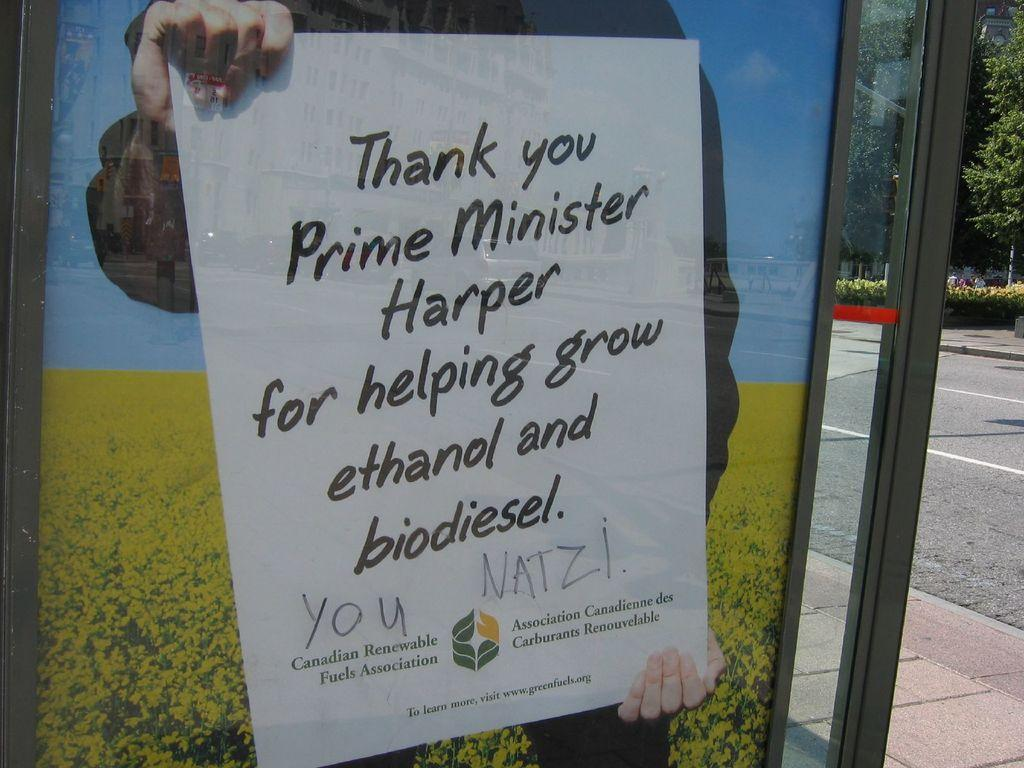What is the main object in the image? There is a board in the image. Who is holding the board? A person is holding the board. What can be seen behind the board? There are plants visible behind the board. What is visible in the background of the image? There is a road and trees present in the background of the image. What type of vegetation is visible in the background of the image? Plants are visible in the background of the image. What type of hook can be seen hanging from the board in the image? There is no hook present on the board in the image. What sound can be heard coming from the plants in the background? There is no sound coming from the plants in the background, as the image is static and does not include any audio. 